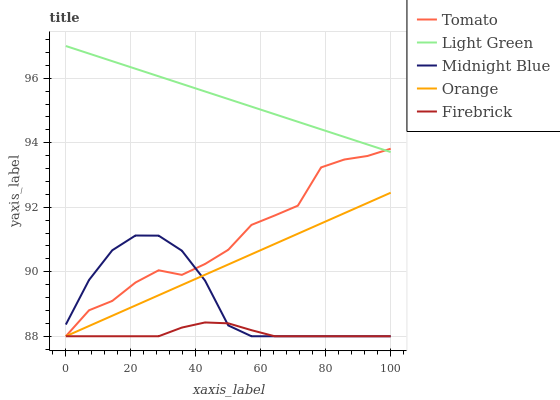Does Firebrick have the minimum area under the curve?
Answer yes or no. Yes. Does Light Green have the maximum area under the curve?
Answer yes or no. Yes. Does Orange have the minimum area under the curve?
Answer yes or no. No. Does Orange have the maximum area under the curve?
Answer yes or no. No. Is Orange the smoothest?
Answer yes or no. Yes. Is Tomato the roughest?
Answer yes or no. Yes. Is Firebrick the smoothest?
Answer yes or no. No. Is Firebrick the roughest?
Answer yes or no. No. Does Tomato have the lowest value?
Answer yes or no. Yes. Does Light Green have the lowest value?
Answer yes or no. No. Does Light Green have the highest value?
Answer yes or no. Yes. Does Orange have the highest value?
Answer yes or no. No. Is Orange less than Light Green?
Answer yes or no. Yes. Is Light Green greater than Midnight Blue?
Answer yes or no. Yes. Does Midnight Blue intersect Orange?
Answer yes or no. Yes. Is Midnight Blue less than Orange?
Answer yes or no. No. Is Midnight Blue greater than Orange?
Answer yes or no. No. Does Orange intersect Light Green?
Answer yes or no. No. 